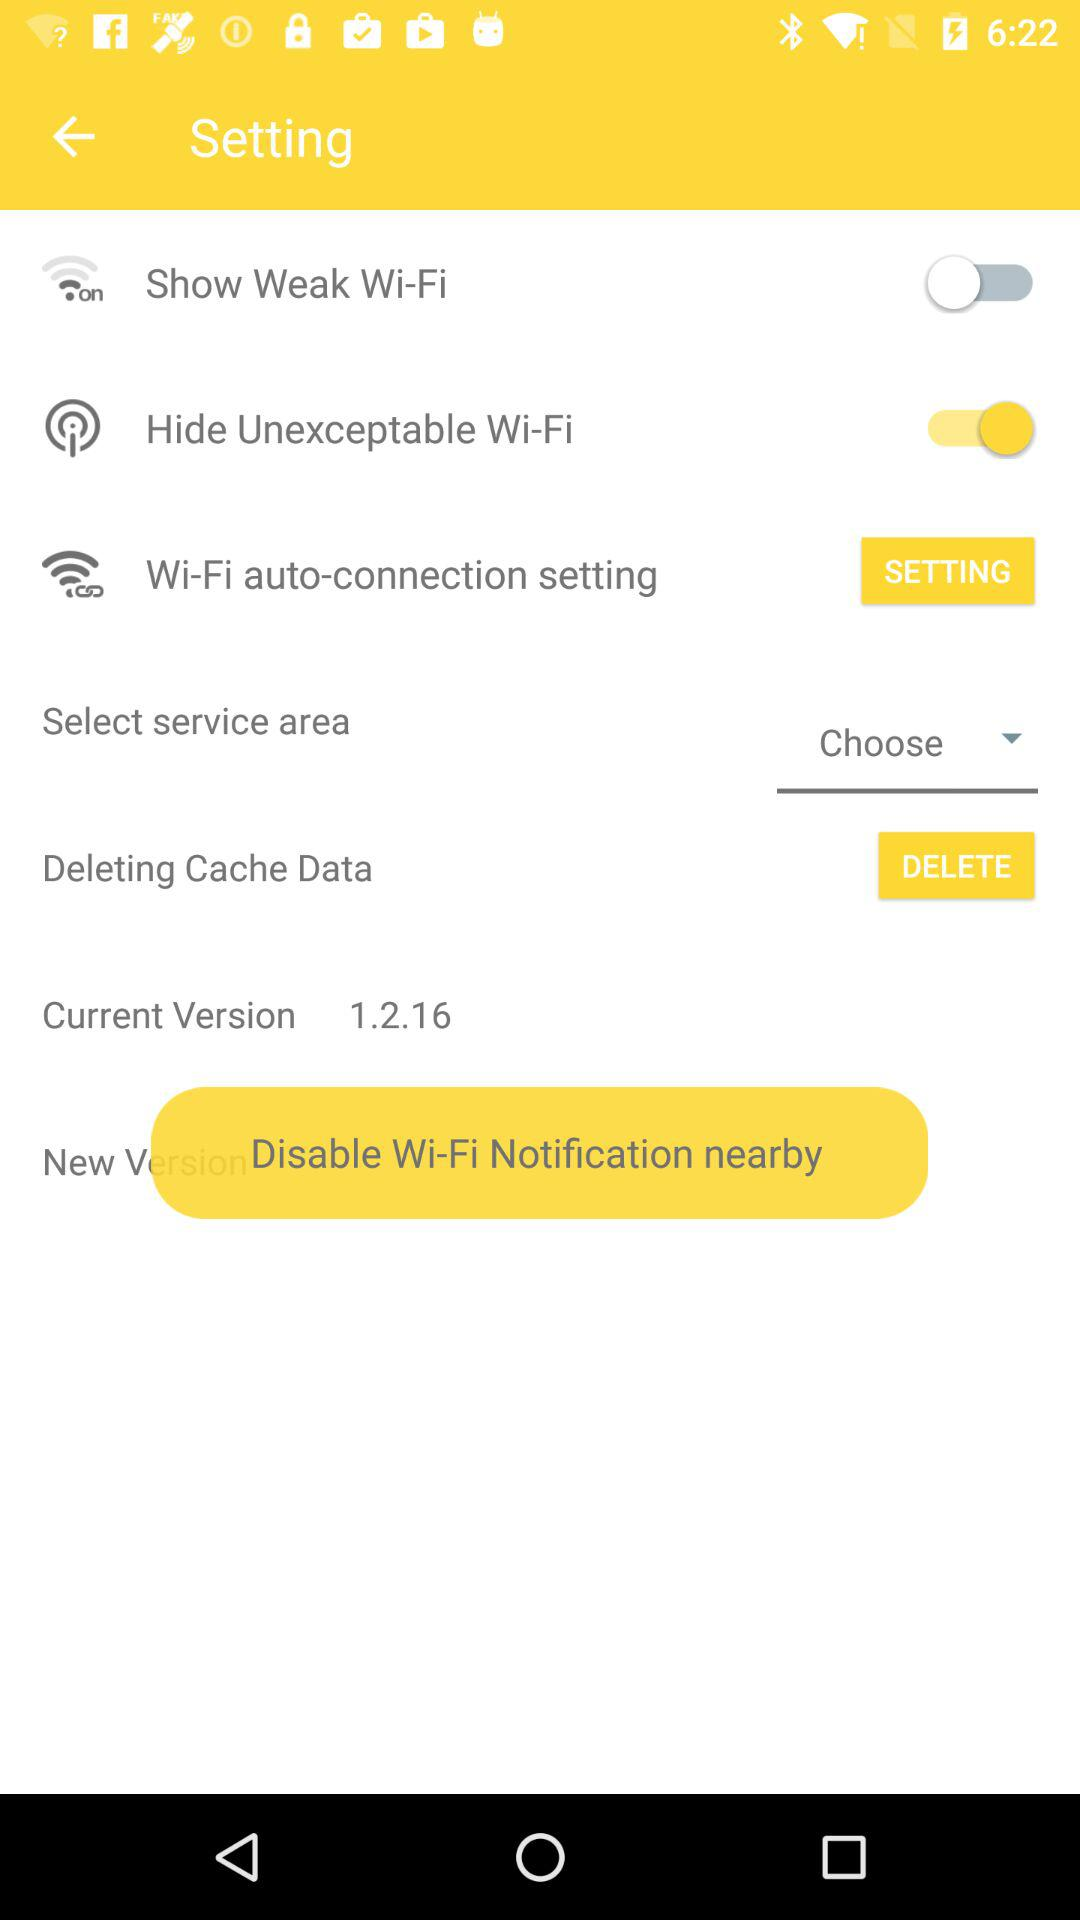What is the status of "Show Weak Wi-Fi"? The status is "off". 